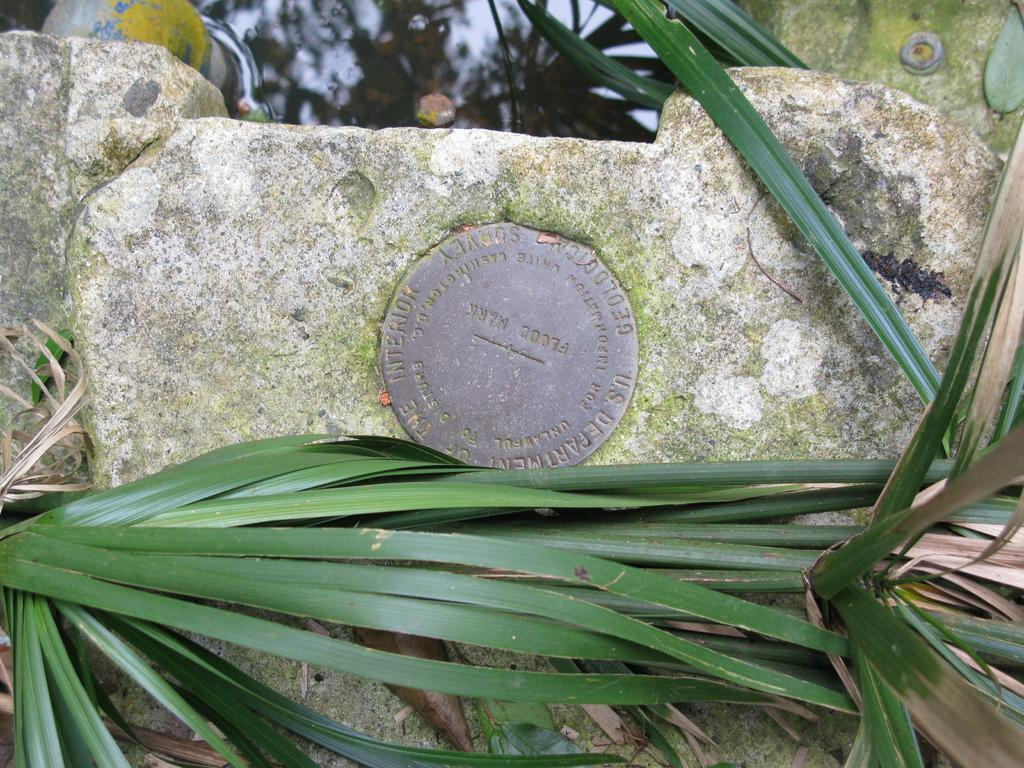What is the main object in the image? There is a rock in the image. What other natural elements can be seen in the image? There are trees in the image. How many frogs are sitting on the rock in the image? There are no frogs present in the image; it only features a rock and trees. What type of quarter is visible on the rock in the image? There is no quarter present on the rock in the image. 